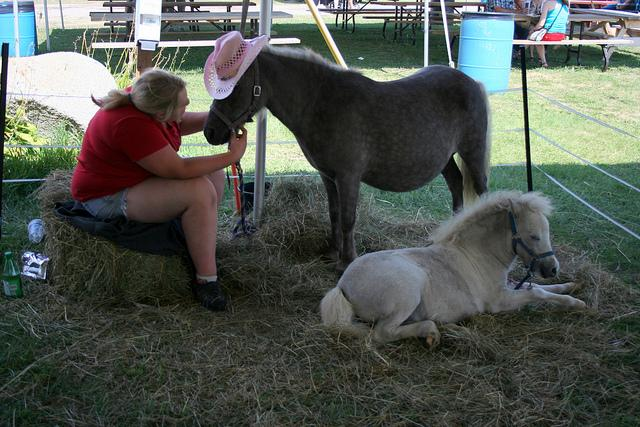The woman is putting what piece of her safety riding gear on the pony?

Choices:
A) harness
B) glasses
C) hat
D) whip harness 